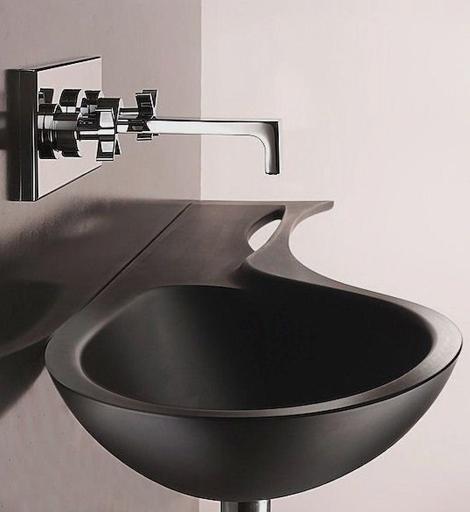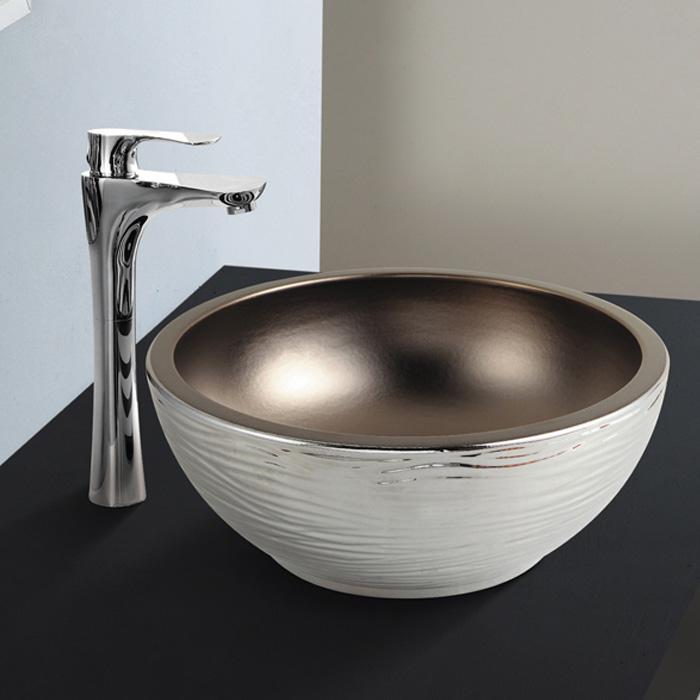The first image is the image on the left, the second image is the image on the right. For the images displayed, is the sentence "The sink in the image on the right is shaped like a bowl." factually correct? Answer yes or no. Yes. 